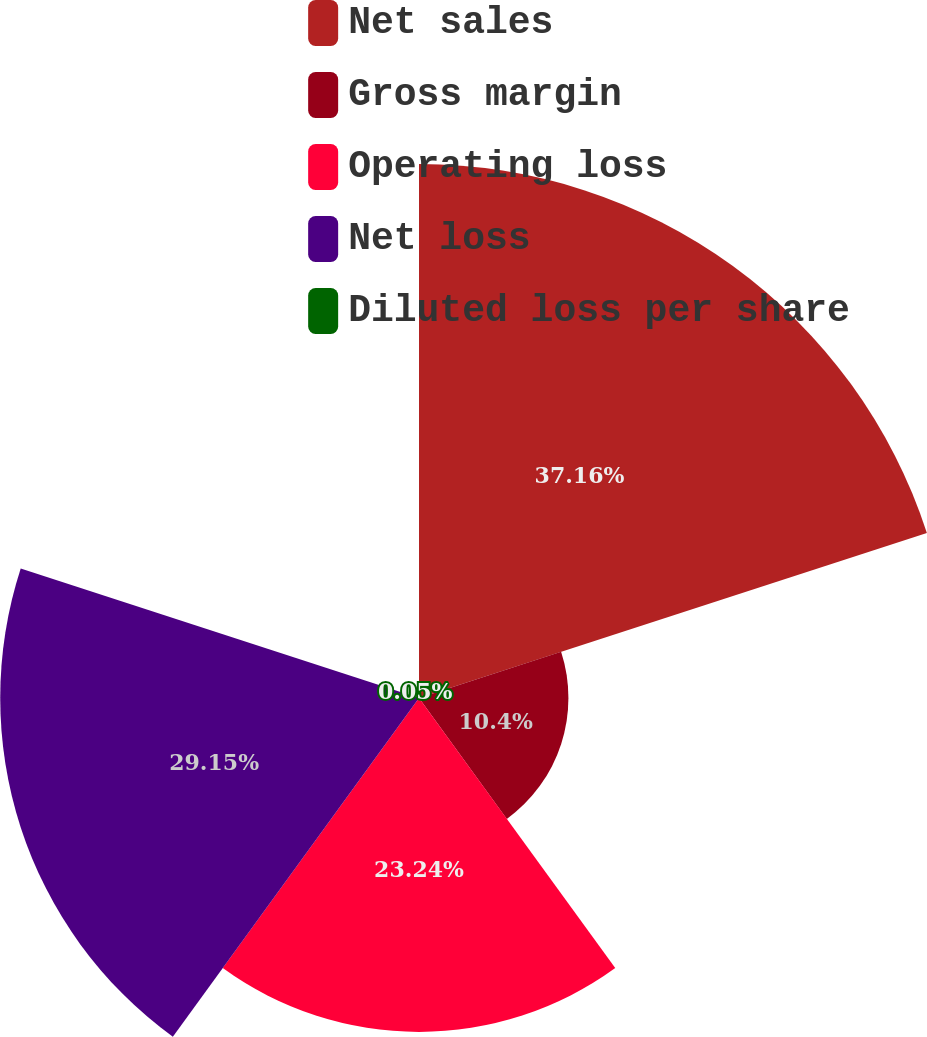<chart> <loc_0><loc_0><loc_500><loc_500><pie_chart><fcel>Net sales<fcel>Gross margin<fcel>Operating loss<fcel>Net loss<fcel>Diluted loss per share<nl><fcel>37.17%<fcel>10.4%<fcel>23.24%<fcel>29.15%<fcel>0.05%<nl></chart> 